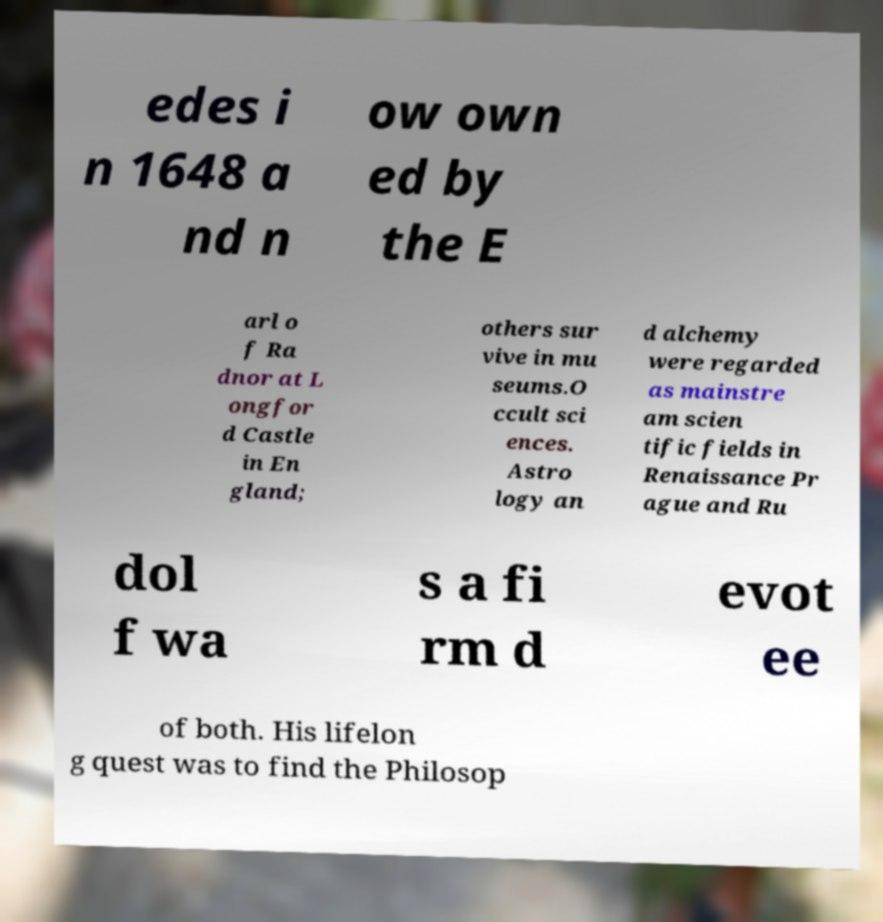Please read and relay the text visible in this image. What does it say? edes i n 1648 a nd n ow own ed by the E arl o f Ra dnor at L ongfor d Castle in En gland; others sur vive in mu seums.O ccult sci ences. Astro logy an d alchemy were regarded as mainstre am scien tific fields in Renaissance Pr ague and Ru dol f wa s a fi rm d evot ee of both. His lifelon g quest was to find the Philosop 